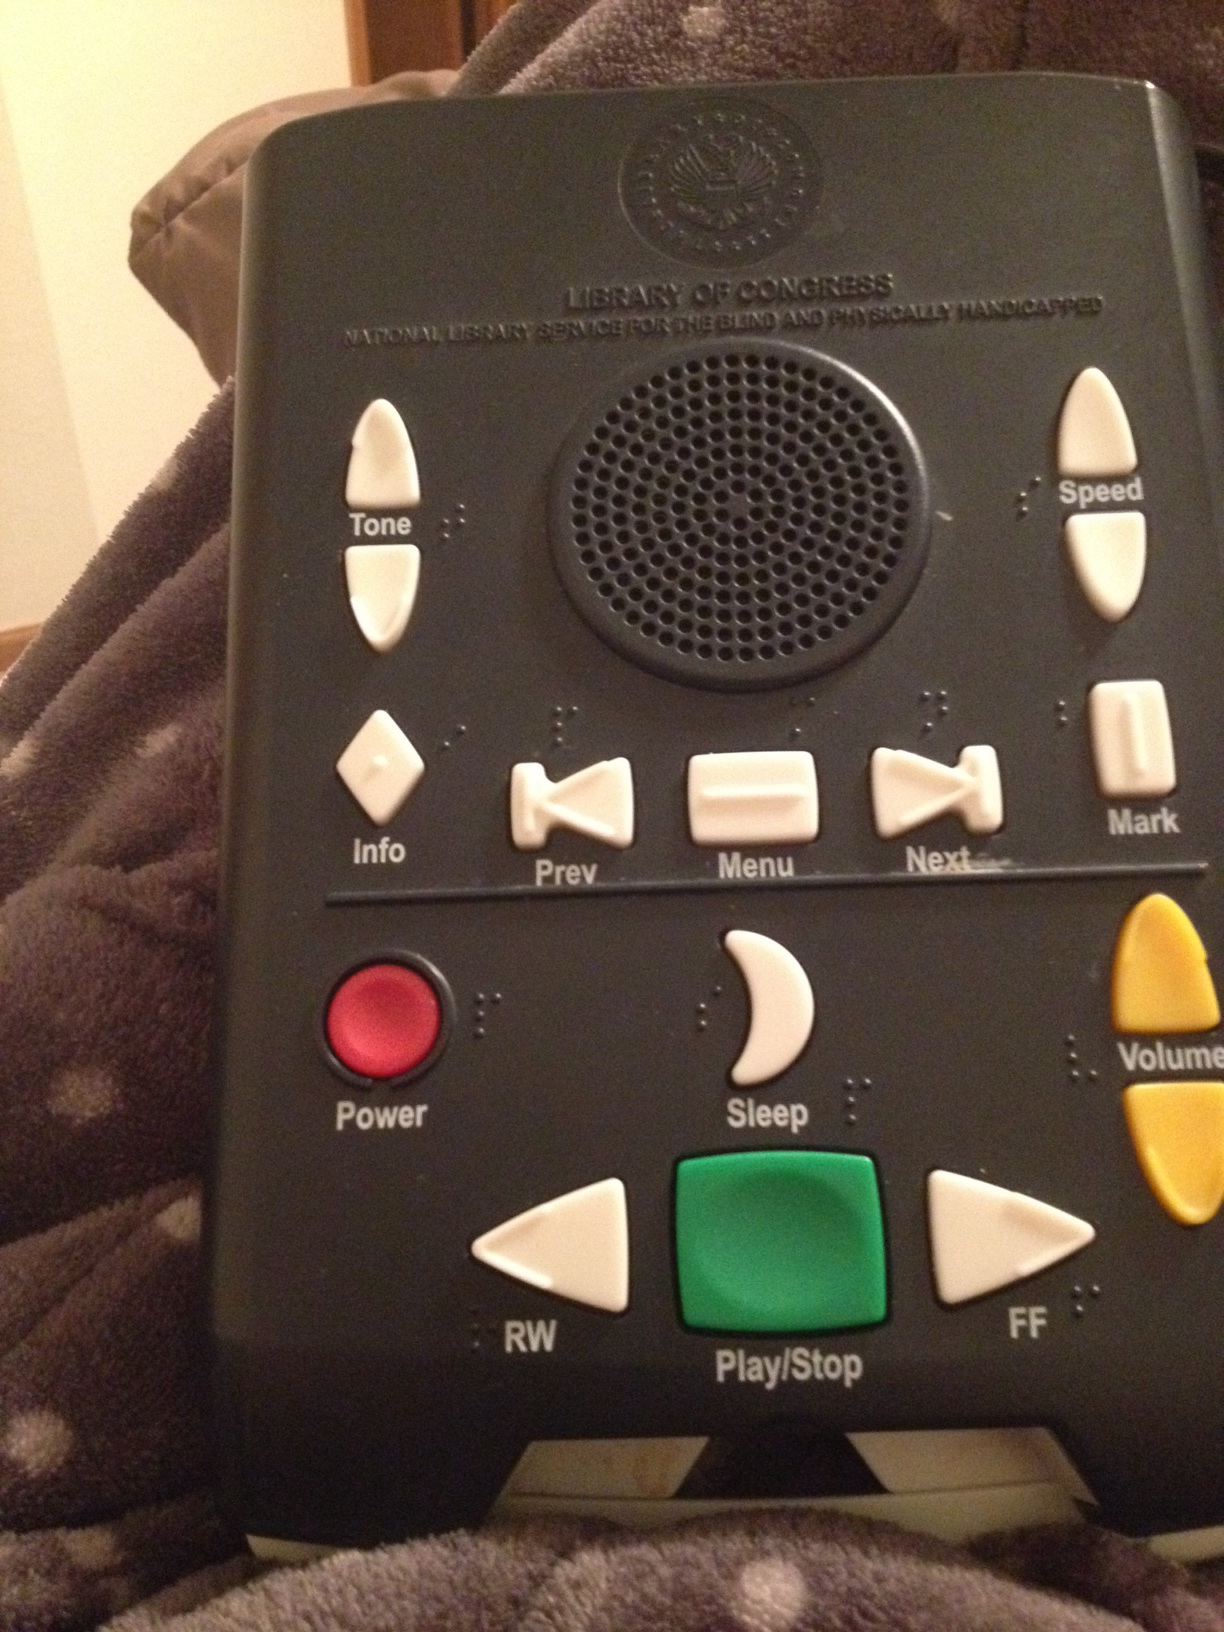What is this? This is an auditory output device designed specifically for the visually impaired. It is used to listen to audio books provided by the Library of Congress, aiding those who have difficulties with vision in accessing printed content. 